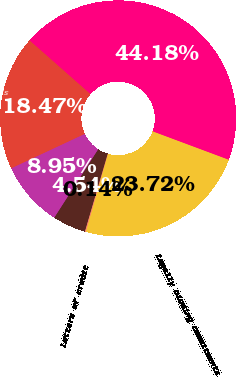Convert chart to OTSL. <chart><loc_0><loc_0><loc_500><loc_500><pie_chart><fcel>Loan commitments<fcel>Home equity lines of credit<fcel>Standby letters of credit and<fcel>Letters of credit<fcel>Legally binding commitments<fcel>Total credit extension<nl><fcel>18.47%<fcel>8.95%<fcel>4.54%<fcel>0.14%<fcel>23.72%<fcel>44.18%<nl></chart> 